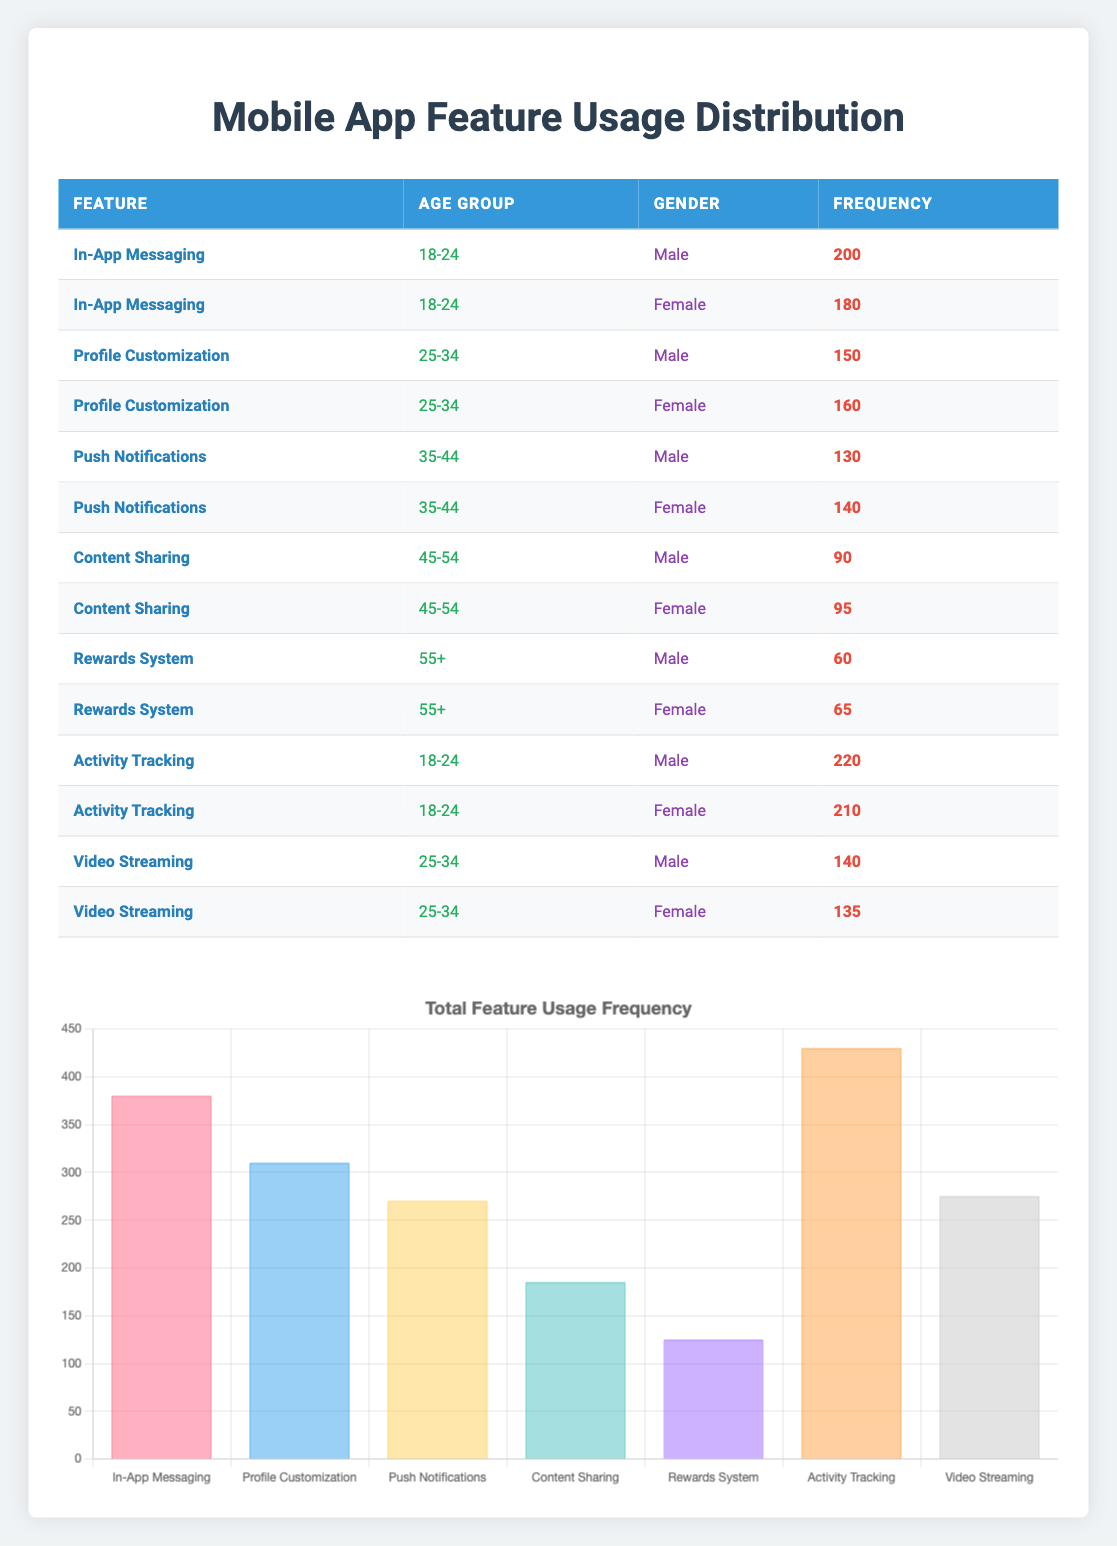What is the frequency of "Activity Tracking" for females aged 18-24? Referring to the table, for the feature "Activity Tracking" under the age group "18-24" and gender "Female," the frequency is 210.
Answer: 210 Which age group has the highest total frequency for "In-App Messaging"? There are two entries for "In-App Messaging," one for the age group "18-24" male (200) and one for "18-24" female (180). Adding these gives a total of 200 + 180 = 380 for age group "18-24," which is the highest total frequency for that feature amongst all age groups.
Answer: 18-24 Is the frequency of "Content Sharing" higher for females or males in the age group 45-54? For the "Content Sharing" feature in the age group 45-54, the frequency for females is 95 and for males is 90. Since 95 (female) is greater than 90 (male), the frequency is higher for females.
Answer: Yes What is the average frequency of feature usage for males aged 25-34? For males aged 25-34, the features are "Profile Customization" (150) and "Video Streaming" (140). To calculate the average, sum these values: 150 + 140 = 290. Then divide by the number of features (2), so the average is 290 / 2 = 145.
Answer: 145 Which gender and age group combination shows the highest frequency usage for "Push Notifications"? The "Push Notifications" frequency for males aged 35-44 is 130 and for females aged 35-44 is 140. Comparing these, the females have the higher frequency.
Answer: Females aged 35-44 What is the total frequency of "Rewards System" across all gender and age groups? The frequency for the "Rewards System" is 60 for males aged 55+ and 65 for females aged 55+. Adding these, we get 60 + 65 = 125, which represents the total frequency for this feature across all groups.
Answer: 125 